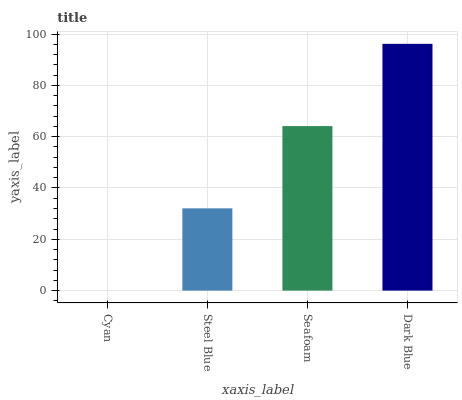Is Cyan the minimum?
Answer yes or no. Yes. Is Dark Blue the maximum?
Answer yes or no. Yes. Is Steel Blue the minimum?
Answer yes or no. No. Is Steel Blue the maximum?
Answer yes or no. No. Is Steel Blue greater than Cyan?
Answer yes or no. Yes. Is Cyan less than Steel Blue?
Answer yes or no. Yes. Is Cyan greater than Steel Blue?
Answer yes or no. No. Is Steel Blue less than Cyan?
Answer yes or no. No. Is Seafoam the high median?
Answer yes or no. Yes. Is Steel Blue the low median?
Answer yes or no. Yes. Is Dark Blue the high median?
Answer yes or no. No. Is Seafoam the low median?
Answer yes or no. No. 